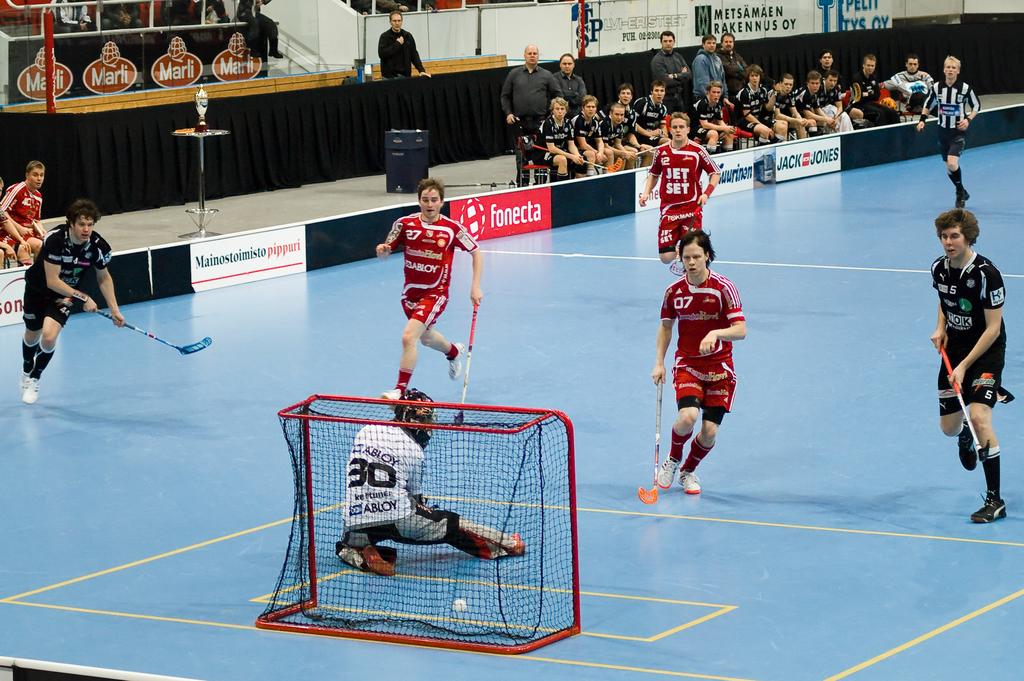What advertisements are on the wall?
Provide a short and direct response. Fonecta. What is the player number of the goalie defender?
Your answer should be very brief. 30. 